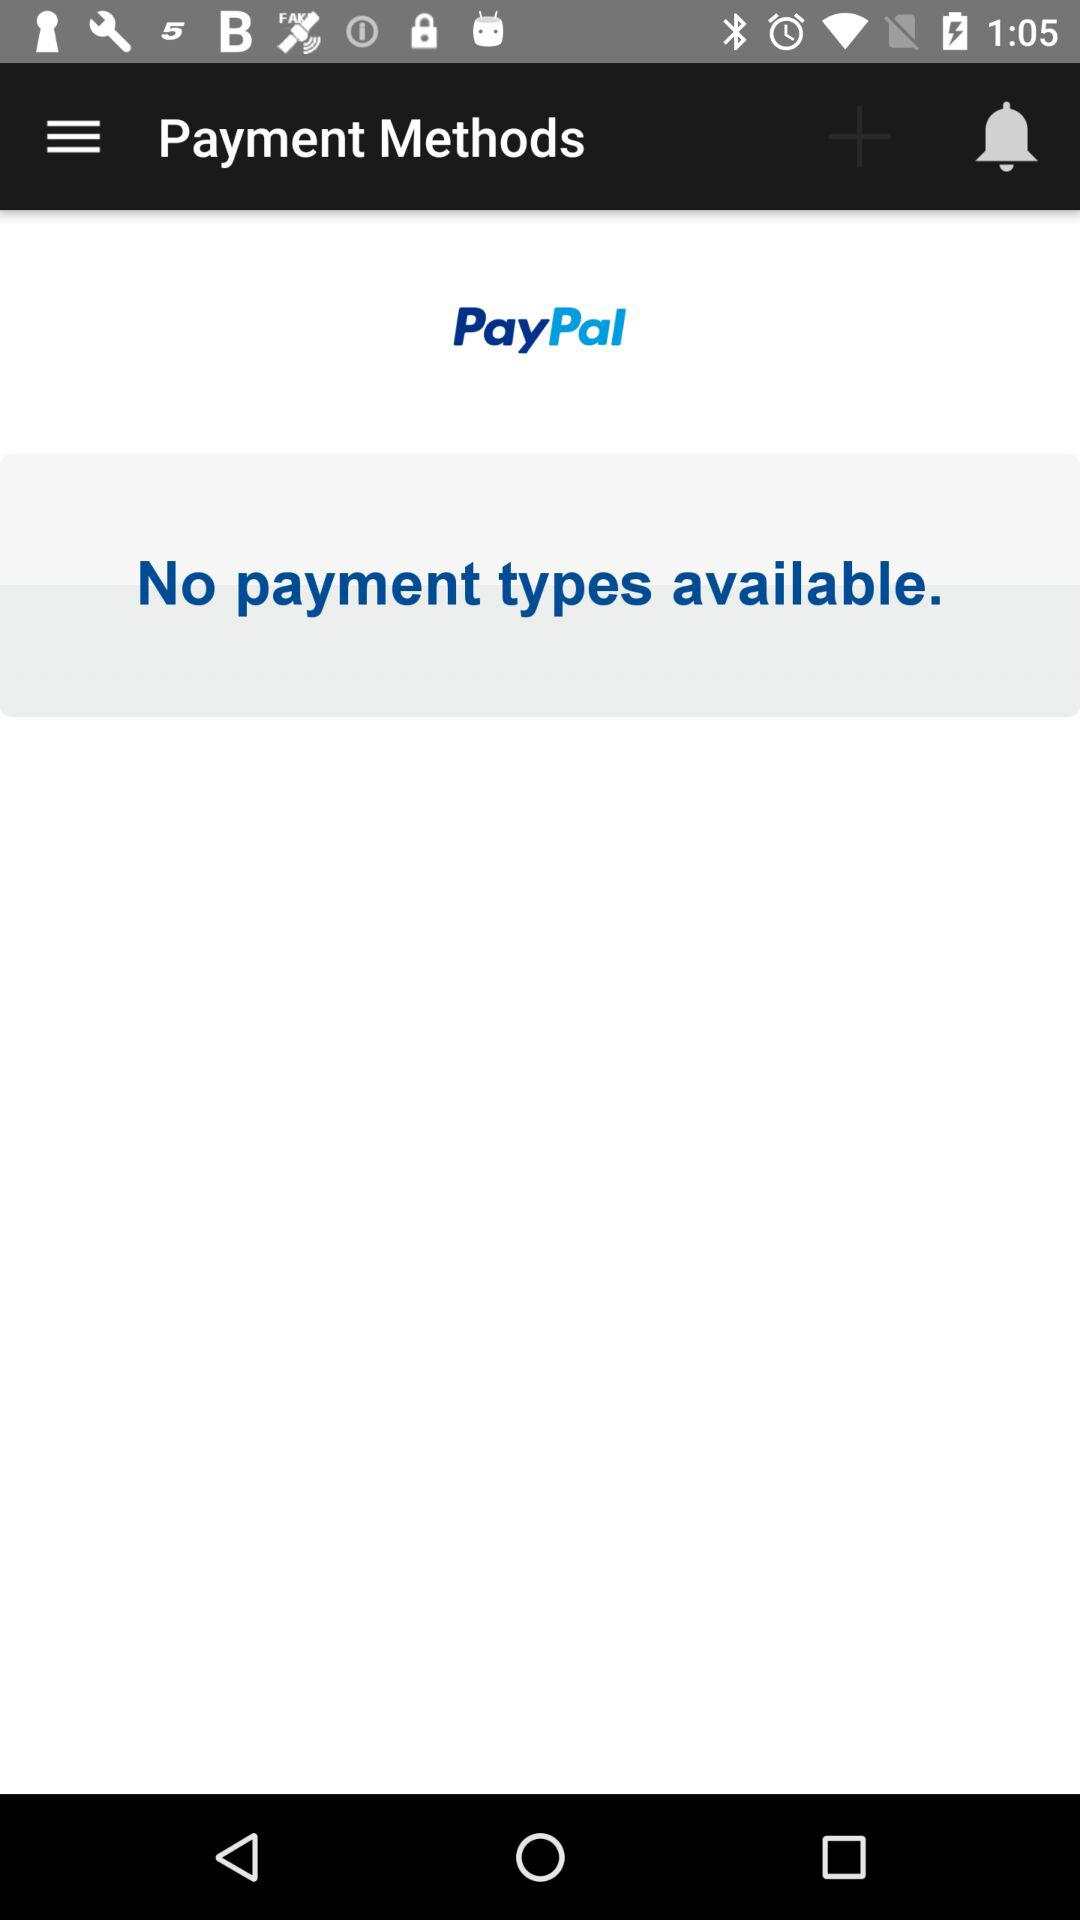When was the last transaction made?
When the provided information is insufficient, respond with <no answer>. <no answer> 